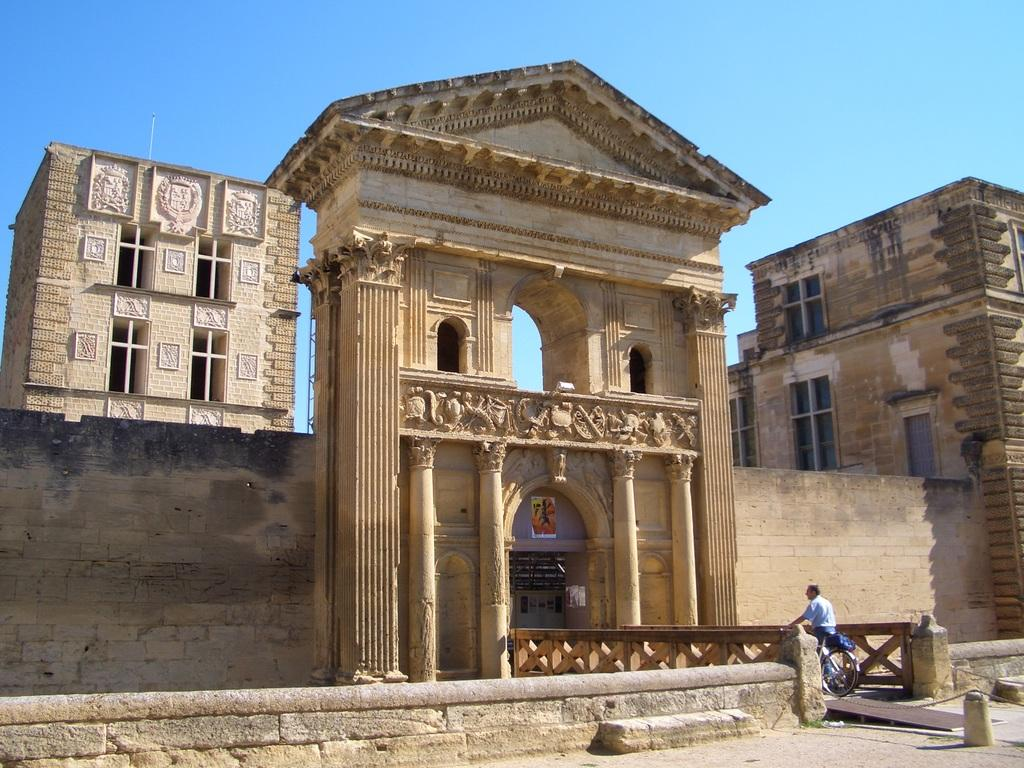What type of structures can be seen in the image? There are buildings in the image. What else is present on the wall in the image? There is a poster on the wall in the image. What is the person in the image using for transportation? The person in the image is on a bicycle. What can be seen in the background of the image? The sky is visible in the background of the image. What type of wine is the person on the bicycle drinking in the image? There is no wine present in the image; the person is on a bicycle. What emotion does the person on the bicycle express in the image? The image does not show any emotions or expressions of regret. 